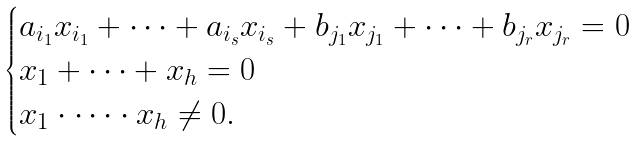<formula> <loc_0><loc_0><loc_500><loc_500>\begin{cases} a _ { i _ { 1 } } x _ { i _ { 1 } } + \dots + a _ { i _ { s } } x _ { i _ { s } } + b _ { j _ { 1 } } x _ { j _ { 1 } } + \dots + b _ { j _ { r } } x _ { j _ { r } } = 0 \\ x _ { 1 } + \dots + x _ { h } = 0 \\ x _ { 1 } \cdot \dots \cdot x _ { h } \ne 0 . \end{cases}</formula> 